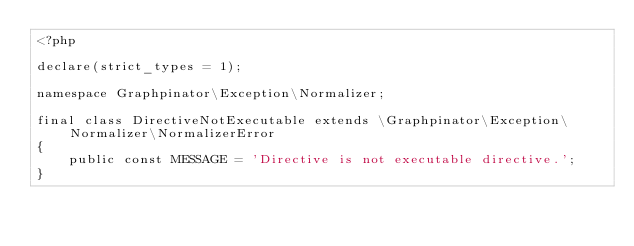Convert code to text. <code><loc_0><loc_0><loc_500><loc_500><_PHP_><?php

declare(strict_types = 1);

namespace Graphpinator\Exception\Normalizer;

final class DirectiveNotExecutable extends \Graphpinator\Exception\Normalizer\NormalizerError
{
    public const MESSAGE = 'Directive is not executable directive.';
}
</code> 